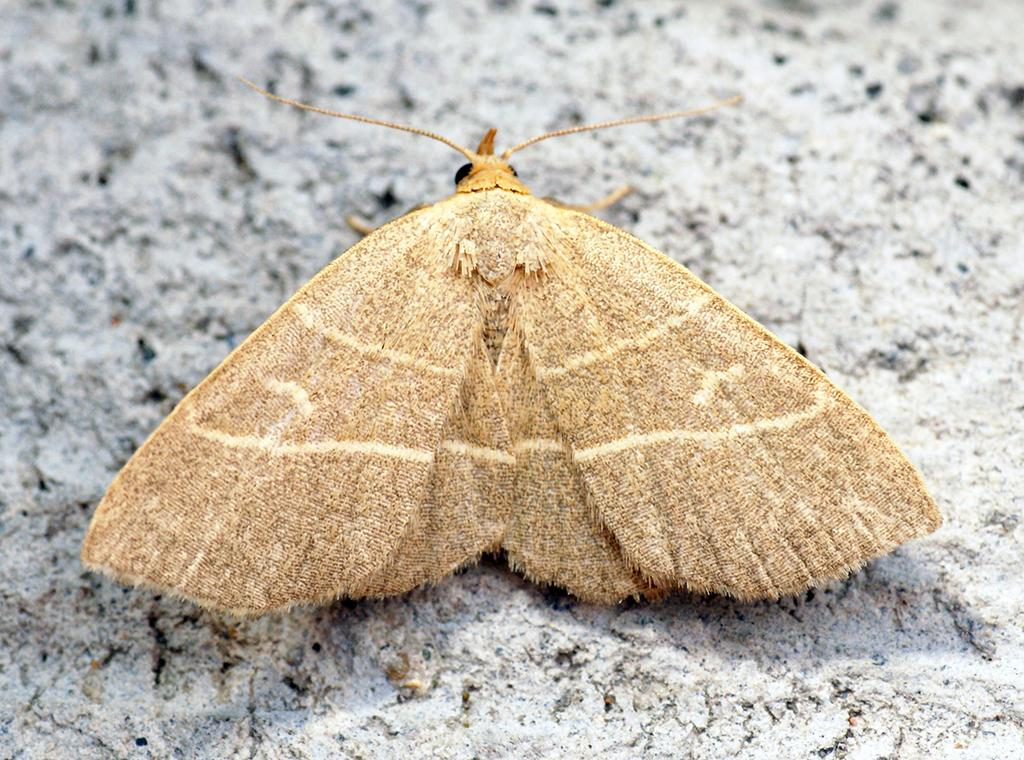What is located in the foreground of the image? There is an insect in the foreground of the image. What is the insect doing in the image? The insect has its wings opened. Where is the insect situated in the image? The insect is on the ground. What type of substance is the sheep consuming in the image? There is no sheep present in the image, and therefore no substance being consumed. 